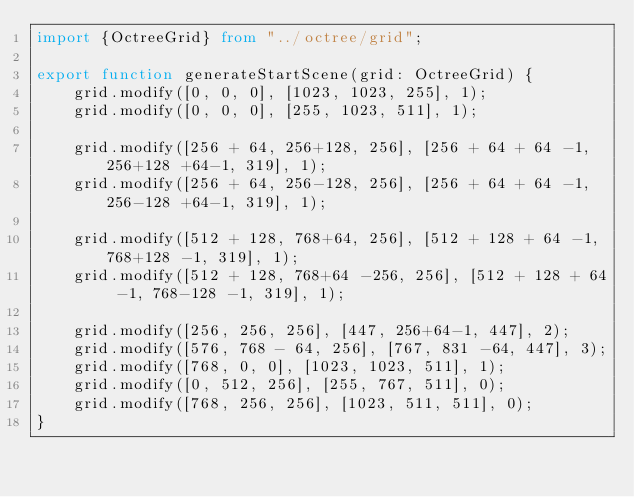Convert code to text. <code><loc_0><loc_0><loc_500><loc_500><_TypeScript_>import {OctreeGrid} from "../octree/grid";

export function generateStartScene(grid: OctreeGrid) {
    grid.modify([0, 0, 0], [1023, 1023, 255], 1);
    grid.modify([0, 0, 0], [255, 1023, 511], 1);

    grid.modify([256 + 64, 256+128, 256], [256 + 64 + 64 -1, 256+128 +64-1, 319], 1);
    grid.modify([256 + 64, 256-128, 256], [256 + 64 + 64 -1, 256-128 +64-1, 319], 1);

    grid.modify([512 + 128, 768+64, 256], [512 + 128 + 64 -1, 768+128 -1, 319], 1);
    grid.modify([512 + 128, 768+64 -256, 256], [512 + 128 + 64 -1, 768-128 -1, 319], 1);

    grid.modify([256, 256, 256], [447, 256+64-1, 447], 2);
    grid.modify([576, 768 - 64, 256], [767, 831 -64, 447], 3);
    grid.modify([768, 0, 0], [1023, 1023, 511], 1);
    grid.modify([0, 512, 256], [255, 767, 511], 0);
    grid.modify([768, 256, 256], [1023, 511, 511], 0);
}</code> 